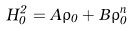<formula> <loc_0><loc_0><loc_500><loc_500>H _ { 0 } ^ { 2 } = A \rho _ { 0 } + B \rho _ { 0 } ^ { n }</formula> 